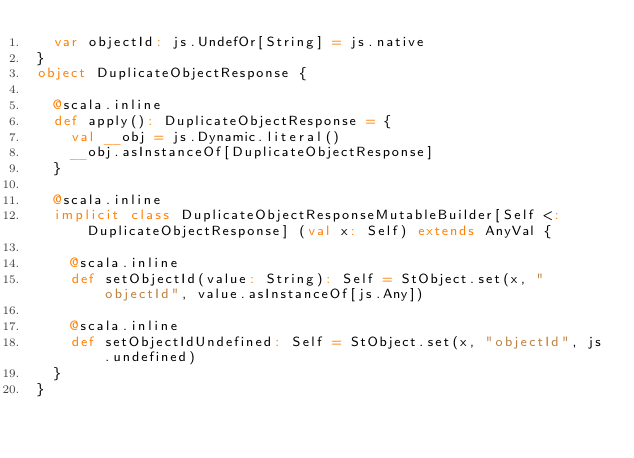Convert code to text. <code><loc_0><loc_0><loc_500><loc_500><_Scala_>  var objectId: js.UndefOr[String] = js.native
}
object DuplicateObjectResponse {
  
  @scala.inline
  def apply(): DuplicateObjectResponse = {
    val __obj = js.Dynamic.literal()
    __obj.asInstanceOf[DuplicateObjectResponse]
  }
  
  @scala.inline
  implicit class DuplicateObjectResponseMutableBuilder[Self <: DuplicateObjectResponse] (val x: Self) extends AnyVal {
    
    @scala.inline
    def setObjectId(value: String): Self = StObject.set(x, "objectId", value.asInstanceOf[js.Any])
    
    @scala.inline
    def setObjectIdUndefined: Self = StObject.set(x, "objectId", js.undefined)
  }
}
</code> 